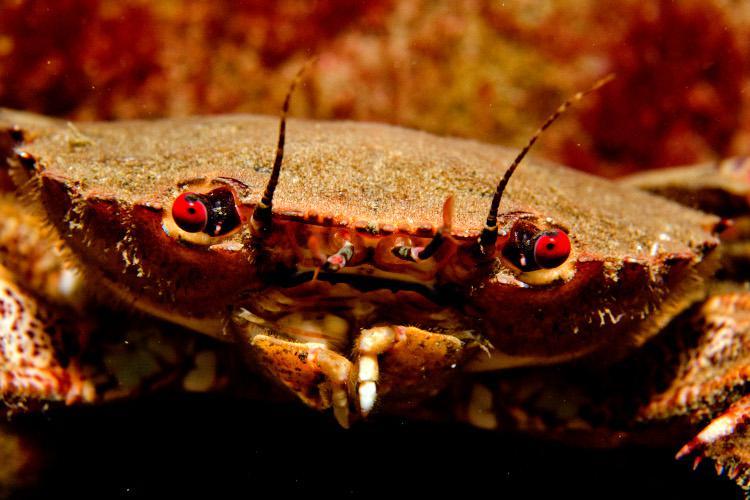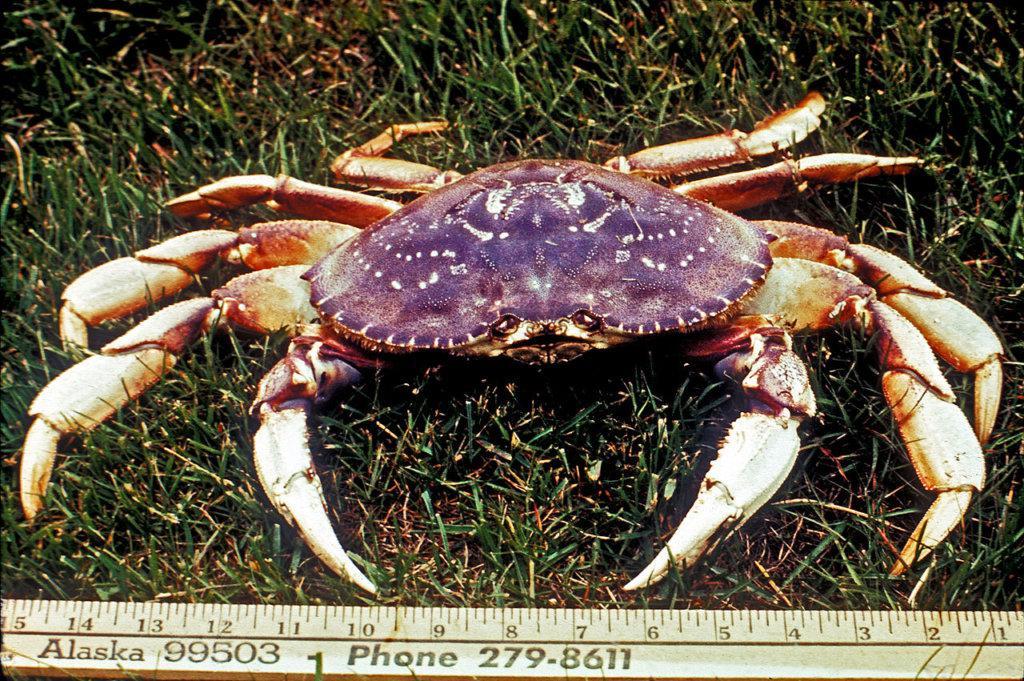The first image is the image on the left, the second image is the image on the right. Analyze the images presented: Is the assertion "Atleast one picture of a crab in water." valid? Answer yes or no. No. The first image is the image on the left, the second image is the image on the right. Analyze the images presented: Is the assertion "The left image shows a mass of crabs with their purplish-grayish shells facing up, and the right image shows one crab toward the bottom of the seabed facing forward at an angle." valid? Answer yes or no. No. 